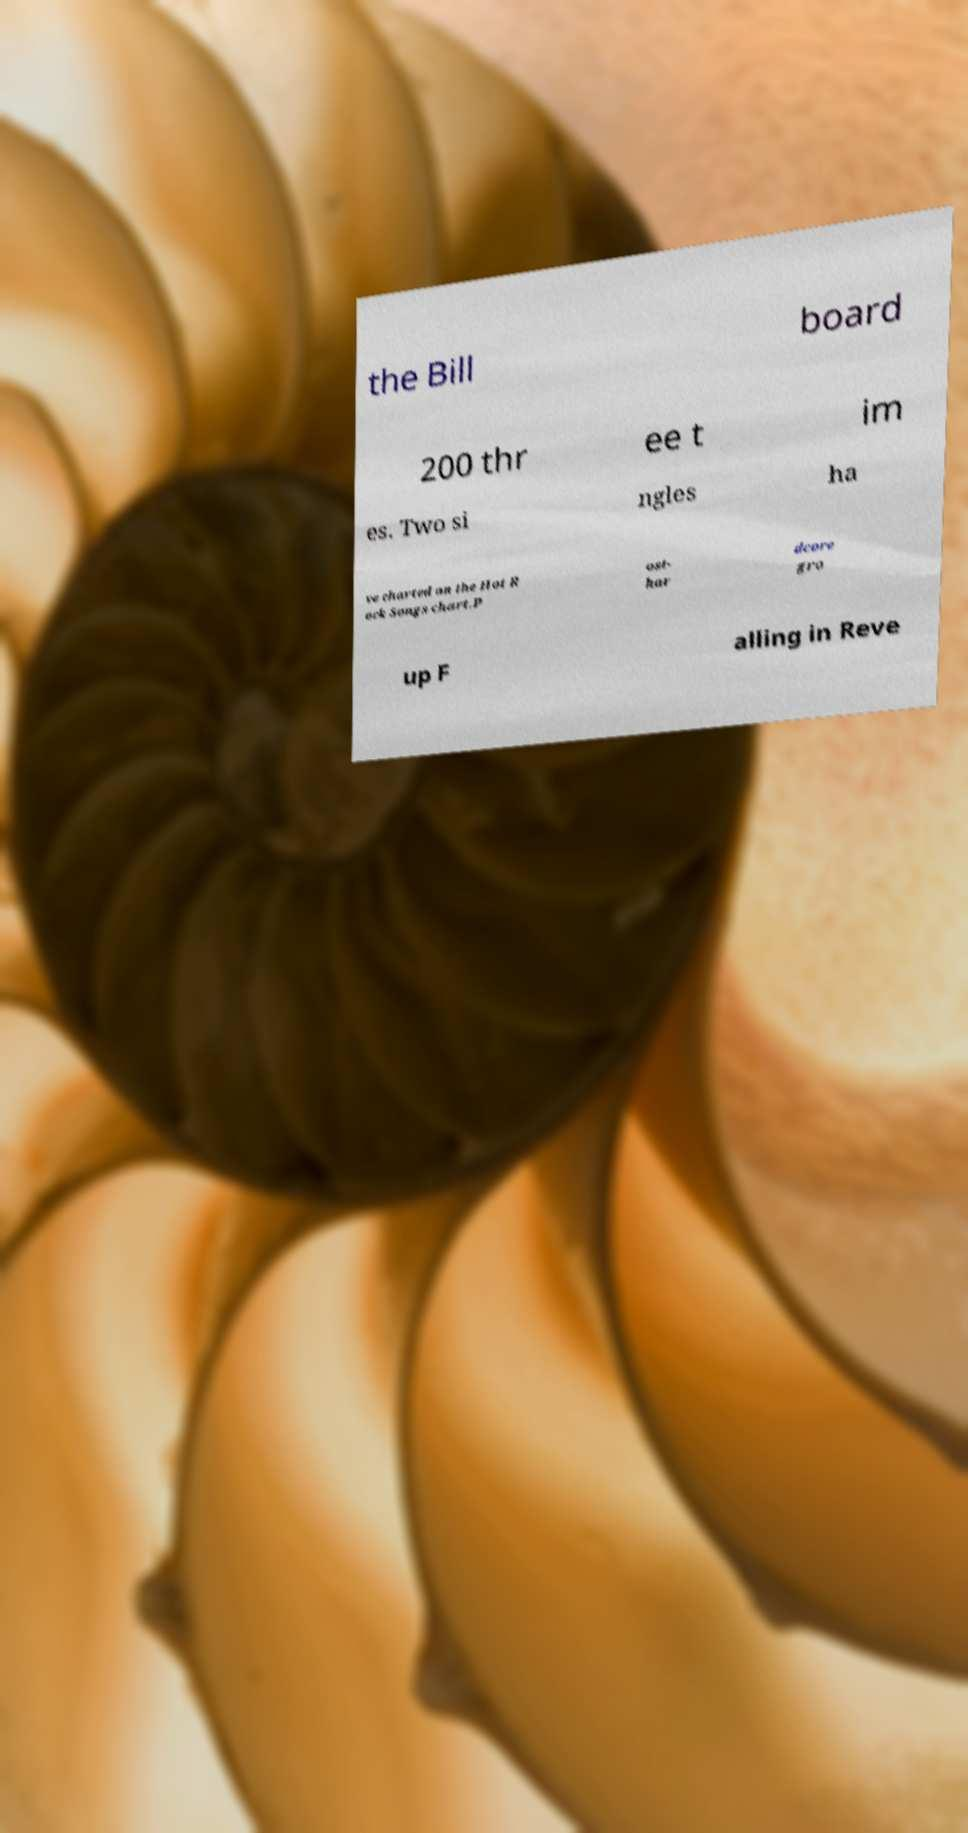Please read and relay the text visible in this image. What does it say? the Bill board 200 thr ee t im es. Two si ngles ha ve charted on the Hot R ock Songs chart.P ost- har dcore gro up F alling in Reve 